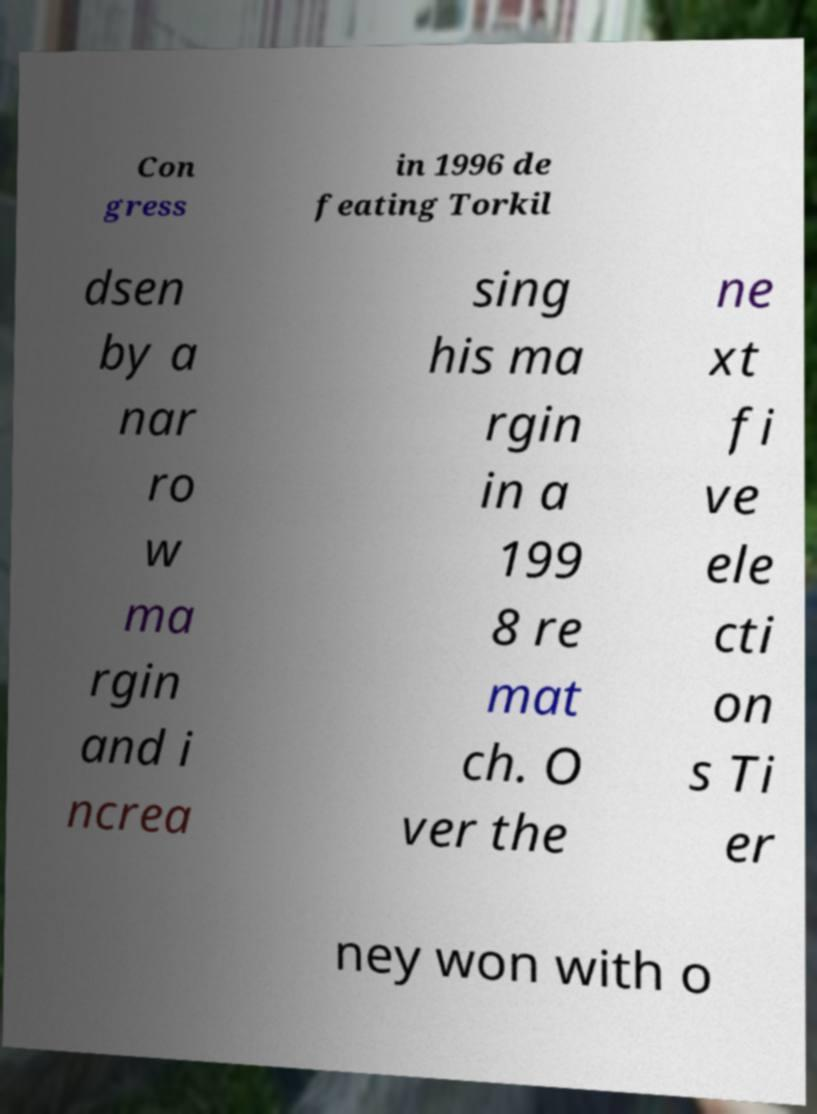Could you assist in decoding the text presented in this image and type it out clearly? Con gress in 1996 de feating Torkil dsen by a nar ro w ma rgin and i ncrea sing his ma rgin in a 199 8 re mat ch. O ver the ne xt fi ve ele cti on s Ti er ney won with o 